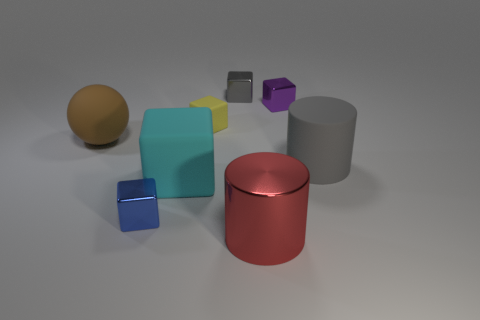Subtract 2 blocks. How many blocks are left? 3 Subtract all blue blocks. How many blocks are left? 4 Subtract all tiny matte blocks. How many blocks are left? 4 Add 2 purple objects. How many objects exist? 10 Subtract all green cubes. Subtract all purple balls. How many cubes are left? 5 Subtract all cylinders. How many objects are left? 6 Add 4 tiny blue cubes. How many tiny blue cubes are left? 5 Add 4 large gray objects. How many large gray objects exist? 5 Subtract 0 cyan cylinders. How many objects are left? 8 Subtract all gray cubes. Subtract all big matte cylinders. How many objects are left? 6 